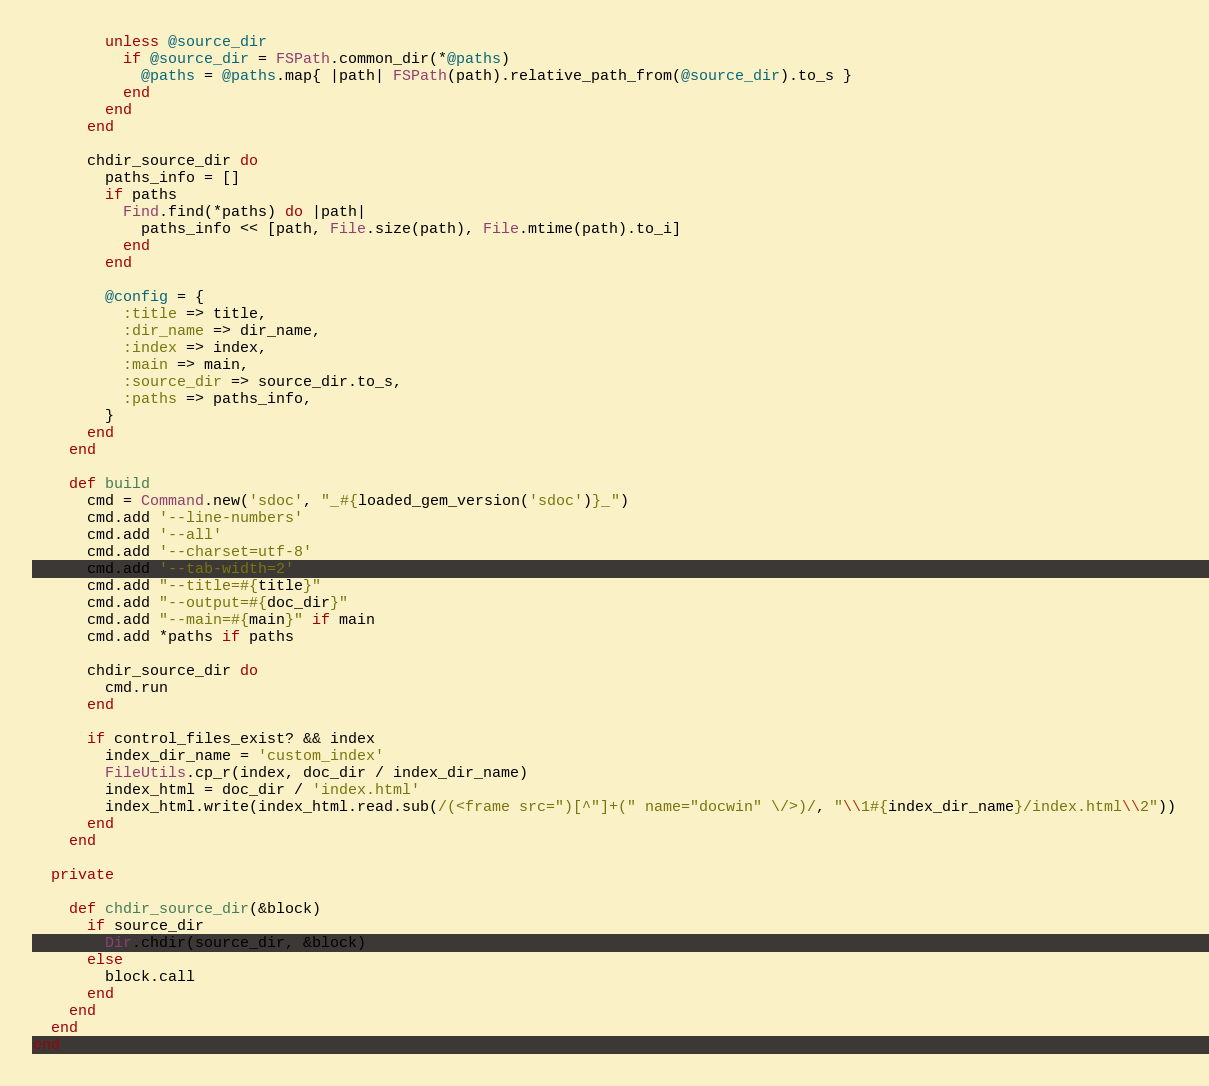<code> <loc_0><loc_0><loc_500><loc_500><_Ruby_>
        unless @source_dir
          if @source_dir = FSPath.common_dir(*@paths)
            @paths = @paths.map{ |path| FSPath(path).relative_path_from(@source_dir).to_s }
          end
        end
      end

      chdir_source_dir do
        paths_info = []
        if paths
          Find.find(*paths) do |path|
            paths_info << [path, File.size(path), File.mtime(path).to_i]
          end
        end

        @config = {
          :title => title,
          :dir_name => dir_name,
          :index => index,
          :main => main,
          :source_dir => source_dir.to_s,
          :paths => paths_info,
        }
      end
    end

    def build
      cmd = Command.new('sdoc', "_#{loaded_gem_version('sdoc')}_")
      cmd.add '--line-numbers'
      cmd.add '--all'
      cmd.add '--charset=utf-8'
      cmd.add '--tab-width=2'
      cmd.add "--title=#{title}"
      cmd.add "--output=#{doc_dir}"
      cmd.add "--main=#{main}" if main
      cmd.add *paths if paths

      chdir_source_dir do
        cmd.run
      end

      if control_files_exist? && index
        index_dir_name = 'custom_index'
        FileUtils.cp_r(index, doc_dir / index_dir_name)
        index_html = doc_dir / 'index.html'
        index_html.write(index_html.read.sub(/(<frame src=")[^"]+(" name="docwin" \/>)/, "\\1#{index_dir_name}/index.html\\2"))
      end
    end

  private

    def chdir_source_dir(&block)
      if source_dir
        Dir.chdir(source_dir, &block)
      else
        block.call
      end
    end
  end
end
</code> 